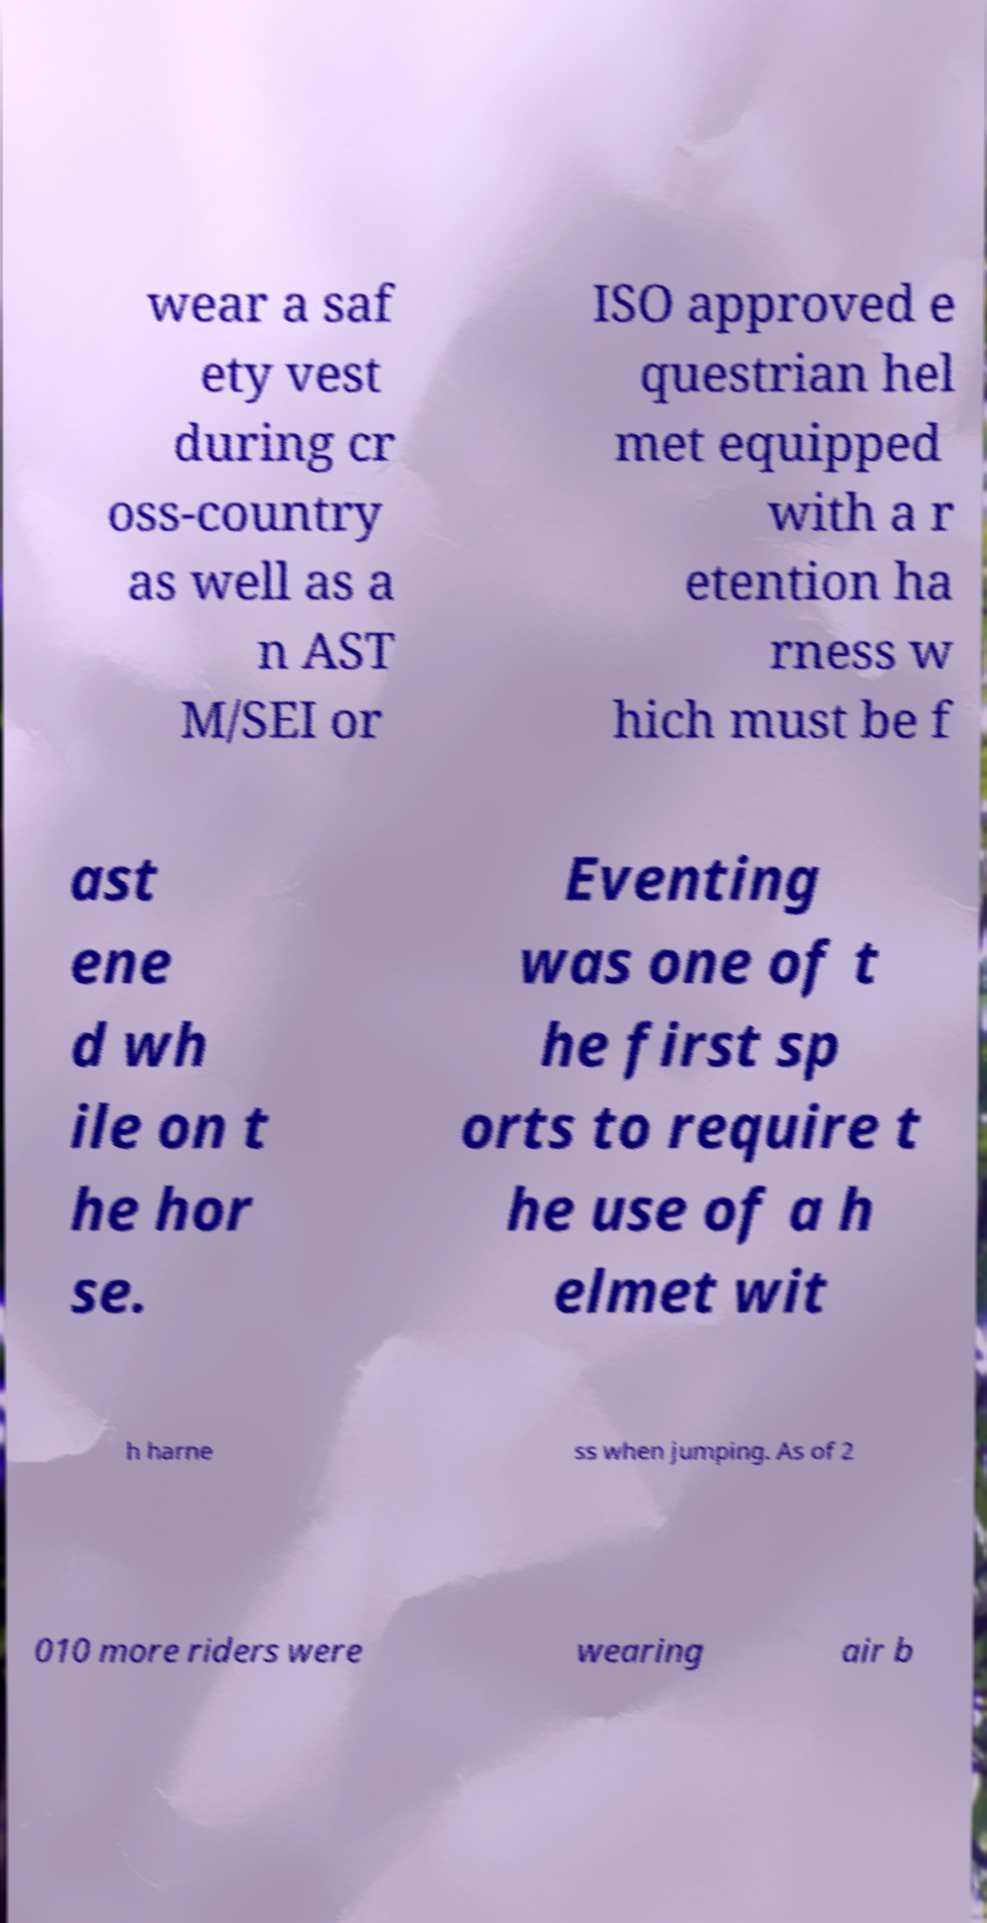What messages or text are displayed in this image? I need them in a readable, typed format. wear a saf ety vest during cr oss-country as well as a n AST M/SEI or ISO approved e questrian hel met equipped with a r etention ha rness w hich must be f ast ene d wh ile on t he hor se. Eventing was one of t he first sp orts to require t he use of a h elmet wit h harne ss when jumping. As of 2 010 more riders were wearing air b 